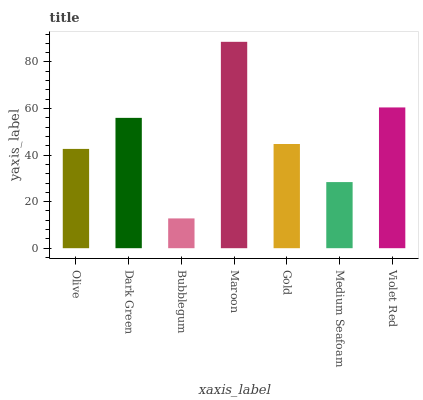Is Bubblegum the minimum?
Answer yes or no. Yes. Is Maroon the maximum?
Answer yes or no. Yes. Is Dark Green the minimum?
Answer yes or no. No. Is Dark Green the maximum?
Answer yes or no. No. Is Dark Green greater than Olive?
Answer yes or no. Yes. Is Olive less than Dark Green?
Answer yes or no. Yes. Is Olive greater than Dark Green?
Answer yes or no. No. Is Dark Green less than Olive?
Answer yes or no. No. Is Gold the high median?
Answer yes or no. Yes. Is Gold the low median?
Answer yes or no. Yes. Is Medium Seafoam the high median?
Answer yes or no. No. Is Dark Green the low median?
Answer yes or no. No. 